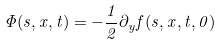Convert formula to latex. <formula><loc_0><loc_0><loc_500><loc_500>\Phi ( s , x , t ) = - \frac { 1 } { 2 } \partial _ { y } f ( s , x , t , 0 )</formula> 